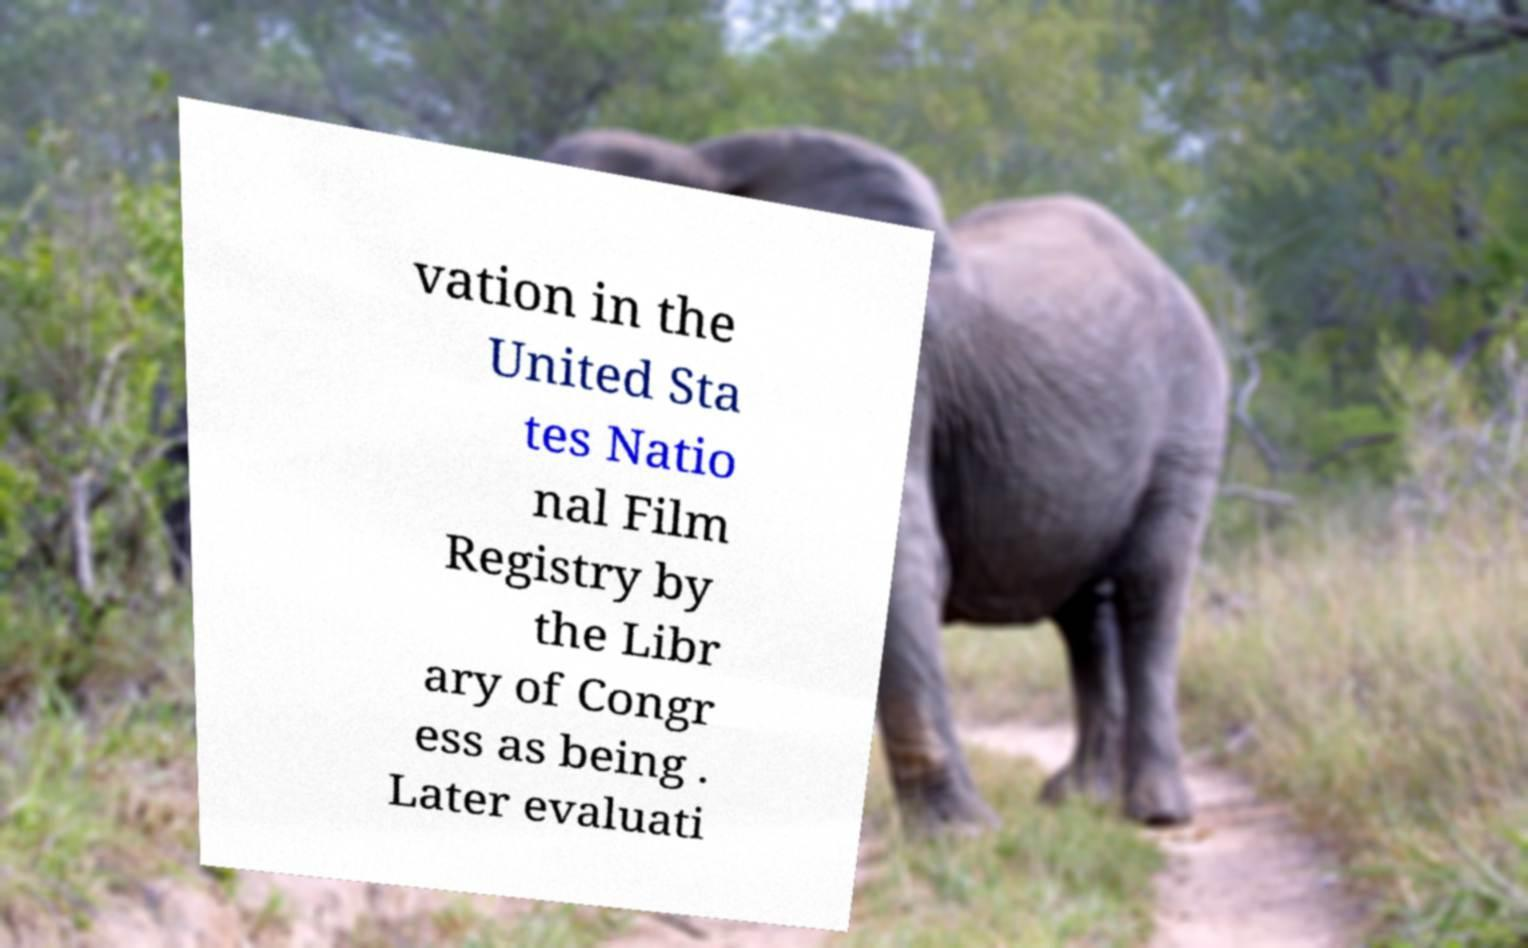Please read and relay the text visible in this image. What does it say? vation in the United Sta tes Natio nal Film Registry by the Libr ary of Congr ess as being . Later evaluati 